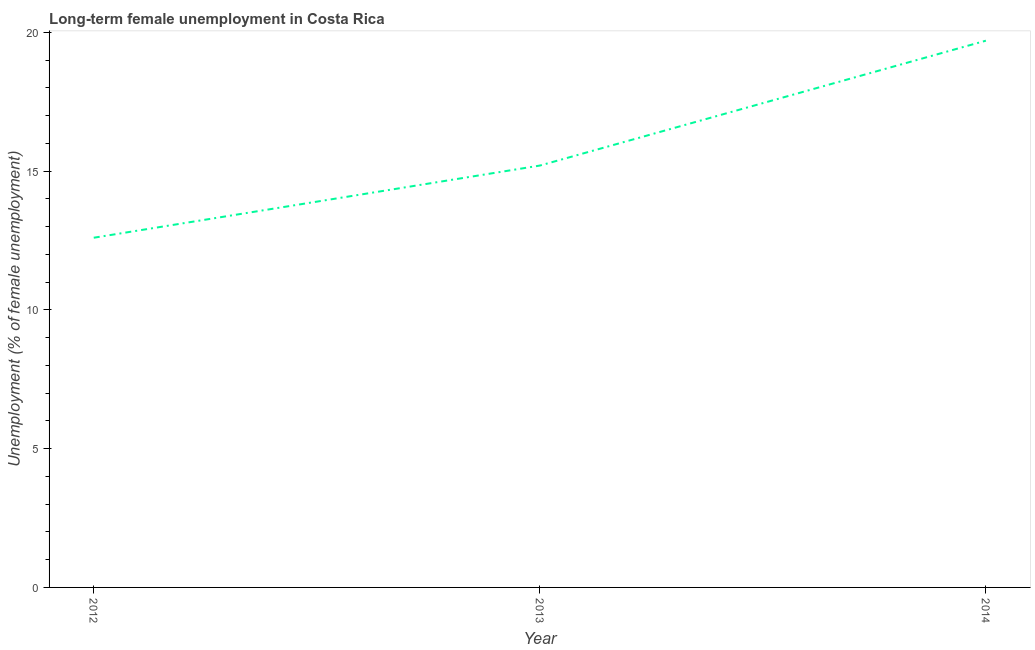What is the long-term female unemployment in 2014?
Make the answer very short. 19.7. Across all years, what is the maximum long-term female unemployment?
Your answer should be compact. 19.7. Across all years, what is the minimum long-term female unemployment?
Your answer should be compact. 12.6. In which year was the long-term female unemployment maximum?
Provide a succinct answer. 2014. In which year was the long-term female unemployment minimum?
Your answer should be very brief. 2012. What is the sum of the long-term female unemployment?
Offer a very short reply. 47.5. What is the difference between the long-term female unemployment in 2012 and 2014?
Your response must be concise. -7.1. What is the average long-term female unemployment per year?
Offer a terse response. 15.83. What is the median long-term female unemployment?
Provide a succinct answer. 15.2. In how many years, is the long-term female unemployment greater than 2 %?
Provide a succinct answer. 3. What is the ratio of the long-term female unemployment in 2012 to that in 2013?
Your response must be concise. 0.83. Is the long-term female unemployment in 2012 less than that in 2014?
Provide a short and direct response. Yes. Is the difference between the long-term female unemployment in 2012 and 2013 greater than the difference between any two years?
Ensure brevity in your answer.  No. What is the difference between the highest and the second highest long-term female unemployment?
Your answer should be compact. 4.5. Is the sum of the long-term female unemployment in 2012 and 2014 greater than the maximum long-term female unemployment across all years?
Make the answer very short. Yes. What is the difference between the highest and the lowest long-term female unemployment?
Provide a succinct answer. 7.1. Does the long-term female unemployment monotonically increase over the years?
Offer a terse response. Yes. How many lines are there?
Give a very brief answer. 1. Are the values on the major ticks of Y-axis written in scientific E-notation?
Provide a succinct answer. No. Does the graph contain any zero values?
Your answer should be compact. No. What is the title of the graph?
Offer a very short reply. Long-term female unemployment in Costa Rica. What is the label or title of the Y-axis?
Ensure brevity in your answer.  Unemployment (% of female unemployment). What is the Unemployment (% of female unemployment) in 2012?
Provide a succinct answer. 12.6. What is the Unemployment (% of female unemployment) in 2013?
Make the answer very short. 15.2. What is the Unemployment (% of female unemployment) of 2014?
Your answer should be very brief. 19.7. What is the difference between the Unemployment (% of female unemployment) in 2012 and 2014?
Ensure brevity in your answer.  -7.1. What is the difference between the Unemployment (% of female unemployment) in 2013 and 2014?
Give a very brief answer. -4.5. What is the ratio of the Unemployment (% of female unemployment) in 2012 to that in 2013?
Ensure brevity in your answer.  0.83. What is the ratio of the Unemployment (% of female unemployment) in 2012 to that in 2014?
Ensure brevity in your answer.  0.64. What is the ratio of the Unemployment (% of female unemployment) in 2013 to that in 2014?
Offer a terse response. 0.77. 